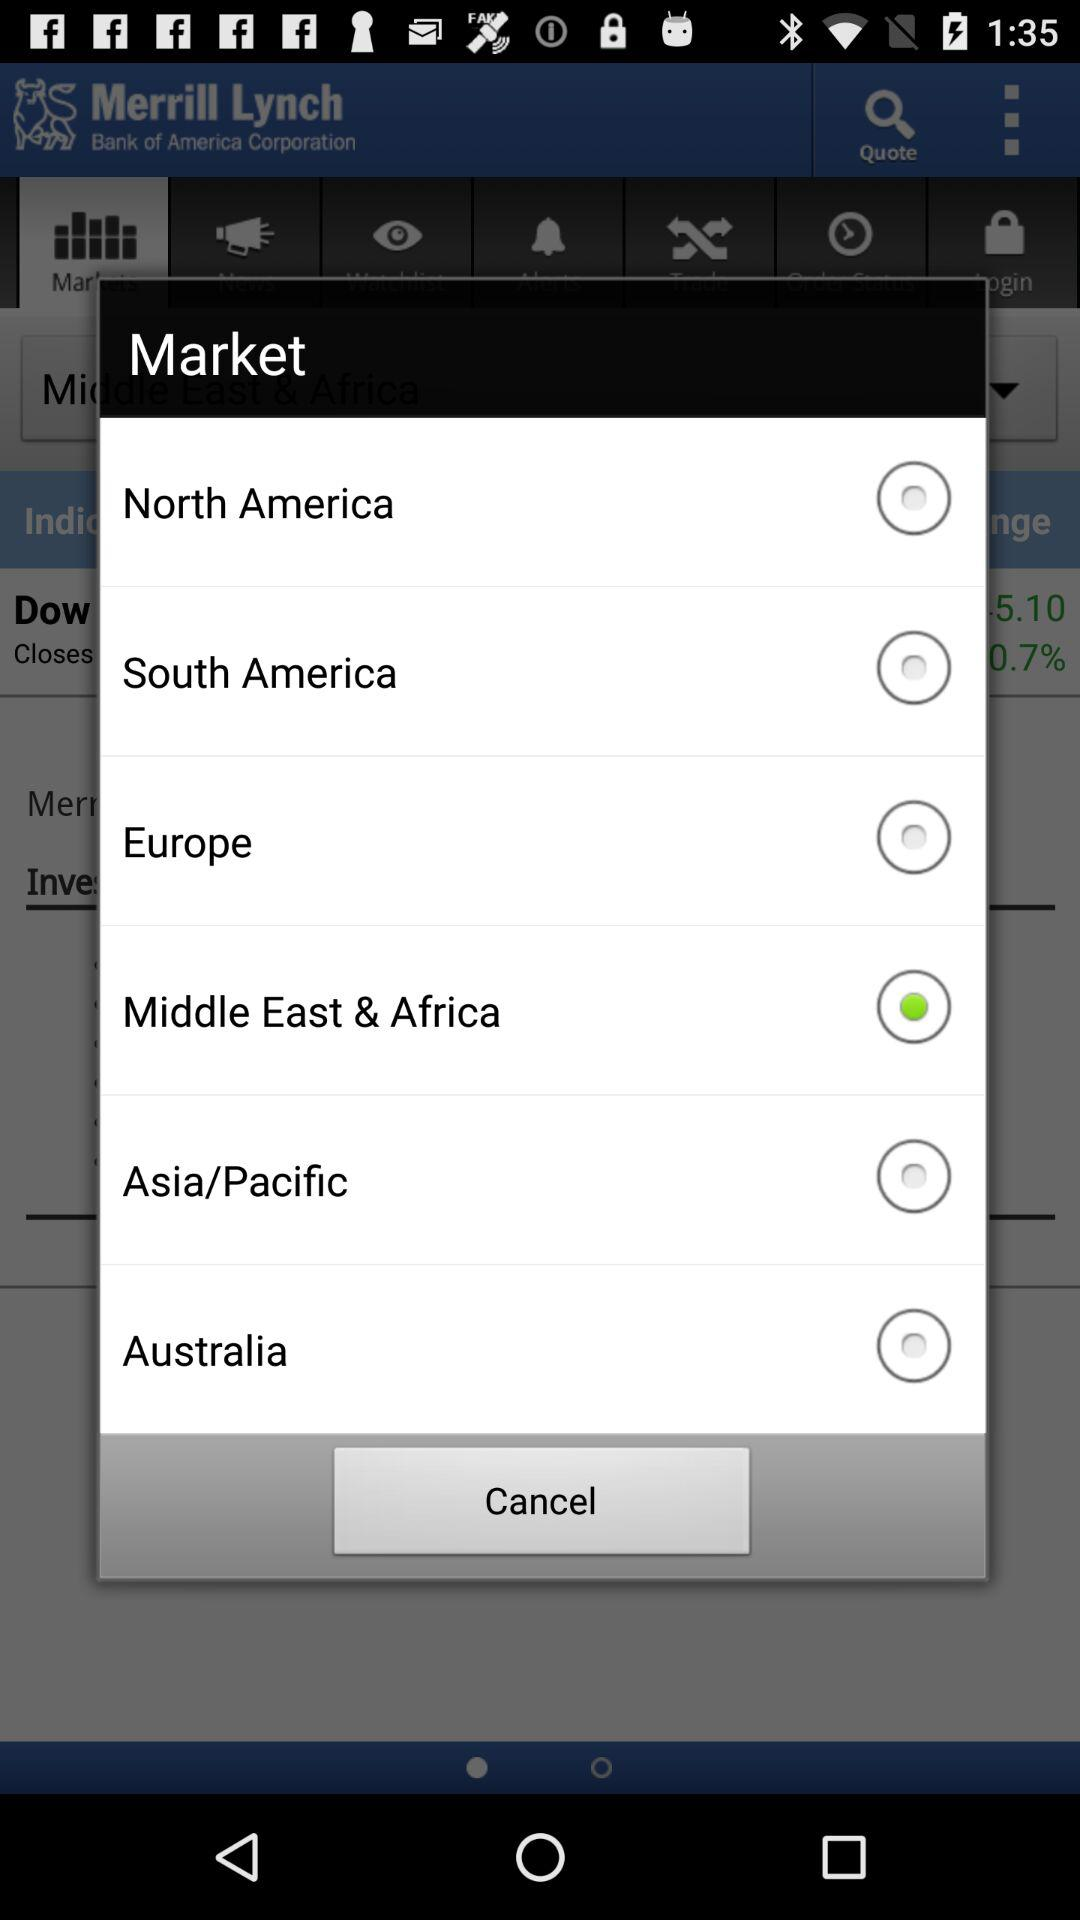What is the time?
When the provided information is insufficient, respond with <no answer>. <no answer> 